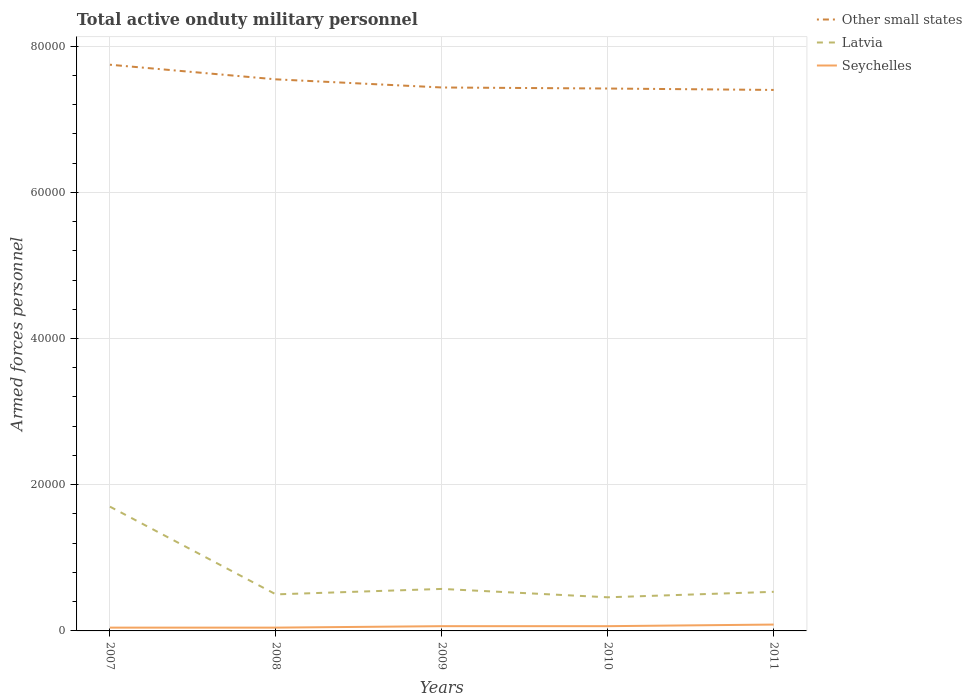Across all years, what is the maximum number of armed forces personnel in Other small states?
Provide a short and direct response. 7.40e+04. In which year was the number of armed forces personnel in Other small states maximum?
Give a very brief answer. 2011. What is the total number of armed forces personnel in Latvia in the graph?
Your response must be concise. 1.24e+04. What is the difference between the highest and the second highest number of armed forces personnel in Seychelles?
Make the answer very short. 420. What is the difference between the highest and the lowest number of armed forces personnel in Seychelles?
Your response must be concise. 3. Is the number of armed forces personnel in Other small states strictly greater than the number of armed forces personnel in Latvia over the years?
Your answer should be compact. No. How many lines are there?
Give a very brief answer. 3. How many years are there in the graph?
Give a very brief answer. 5. Does the graph contain grids?
Offer a very short reply. Yes. Where does the legend appear in the graph?
Give a very brief answer. Top right. How many legend labels are there?
Keep it short and to the point. 3. What is the title of the graph?
Your answer should be compact. Total active onduty military personnel. Does "Angola" appear as one of the legend labels in the graph?
Provide a succinct answer. No. What is the label or title of the Y-axis?
Provide a succinct answer. Armed forces personnel. What is the Armed forces personnel of Other small states in 2007?
Your response must be concise. 7.74e+04. What is the Armed forces personnel in Latvia in 2007?
Make the answer very short. 1.70e+04. What is the Armed forces personnel of Seychelles in 2007?
Your answer should be compact. 450. What is the Armed forces personnel in Other small states in 2008?
Your answer should be very brief. 7.54e+04. What is the Armed forces personnel in Seychelles in 2008?
Keep it short and to the point. 450. What is the Armed forces personnel of Other small states in 2009?
Ensure brevity in your answer.  7.43e+04. What is the Armed forces personnel of Latvia in 2009?
Provide a succinct answer. 5745. What is the Armed forces personnel in Seychelles in 2009?
Offer a terse response. 650. What is the Armed forces personnel of Other small states in 2010?
Provide a succinct answer. 7.42e+04. What is the Armed forces personnel in Latvia in 2010?
Offer a very short reply. 4600. What is the Armed forces personnel of Seychelles in 2010?
Make the answer very short. 650. What is the Armed forces personnel of Other small states in 2011?
Offer a very short reply. 7.40e+04. What is the Armed forces personnel of Latvia in 2011?
Offer a very short reply. 5350. What is the Armed forces personnel of Seychelles in 2011?
Give a very brief answer. 870. Across all years, what is the maximum Armed forces personnel of Other small states?
Provide a succinct answer. 7.74e+04. Across all years, what is the maximum Armed forces personnel in Latvia?
Offer a very short reply. 1.70e+04. Across all years, what is the maximum Armed forces personnel in Seychelles?
Provide a succinct answer. 870. Across all years, what is the minimum Armed forces personnel of Other small states?
Make the answer very short. 7.40e+04. Across all years, what is the minimum Armed forces personnel in Latvia?
Offer a very short reply. 4600. Across all years, what is the minimum Armed forces personnel in Seychelles?
Provide a succinct answer. 450. What is the total Armed forces personnel of Other small states in the graph?
Make the answer very short. 3.75e+05. What is the total Armed forces personnel in Latvia in the graph?
Offer a very short reply. 3.77e+04. What is the total Armed forces personnel in Seychelles in the graph?
Your answer should be compact. 3070. What is the difference between the Armed forces personnel of Other small states in 2007 and that in 2008?
Give a very brief answer. 2000. What is the difference between the Armed forces personnel in Latvia in 2007 and that in 2008?
Keep it short and to the point. 1.20e+04. What is the difference between the Armed forces personnel in Other small states in 2007 and that in 2009?
Offer a very short reply. 3113. What is the difference between the Armed forces personnel of Latvia in 2007 and that in 2009?
Your answer should be compact. 1.13e+04. What is the difference between the Armed forces personnel of Seychelles in 2007 and that in 2009?
Your answer should be very brief. -200. What is the difference between the Armed forces personnel in Other small states in 2007 and that in 2010?
Offer a terse response. 3256. What is the difference between the Armed forces personnel of Latvia in 2007 and that in 2010?
Your answer should be compact. 1.24e+04. What is the difference between the Armed forces personnel of Seychelles in 2007 and that in 2010?
Your answer should be compact. -200. What is the difference between the Armed forces personnel of Other small states in 2007 and that in 2011?
Provide a short and direct response. 3450. What is the difference between the Armed forces personnel of Latvia in 2007 and that in 2011?
Give a very brief answer. 1.16e+04. What is the difference between the Armed forces personnel in Seychelles in 2007 and that in 2011?
Your answer should be compact. -420. What is the difference between the Armed forces personnel in Other small states in 2008 and that in 2009?
Give a very brief answer. 1113. What is the difference between the Armed forces personnel of Latvia in 2008 and that in 2009?
Your response must be concise. -745. What is the difference between the Armed forces personnel in Seychelles in 2008 and that in 2009?
Offer a terse response. -200. What is the difference between the Armed forces personnel in Other small states in 2008 and that in 2010?
Make the answer very short. 1256. What is the difference between the Armed forces personnel in Latvia in 2008 and that in 2010?
Provide a short and direct response. 400. What is the difference between the Armed forces personnel in Seychelles in 2008 and that in 2010?
Keep it short and to the point. -200. What is the difference between the Armed forces personnel of Other small states in 2008 and that in 2011?
Your answer should be very brief. 1450. What is the difference between the Armed forces personnel of Latvia in 2008 and that in 2011?
Your answer should be compact. -350. What is the difference between the Armed forces personnel of Seychelles in 2008 and that in 2011?
Your answer should be compact. -420. What is the difference between the Armed forces personnel in Other small states in 2009 and that in 2010?
Provide a succinct answer. 143. What is the difference between the Armed forces personnel of Latvia in 2009 and that in 2010?
Your answer should be compact. 1145. What is the difference between the Armed forces personnel in Seychelles in 2009 and that in 2010?
Keep it short and to the point. 0. What is the difference between the Armed forces personnel in Other small states in 2009 and that in 2011?
Provide a succinct answer. 337. What is the difference between the Armed forces personnel of Latvia in 2009 and that in 2011?
Your answer should be very brief. 395. What is the difference between the Armed forces personnel in Seychelles in 2009 and that in 2011?
Provide a succinct answer. -220. What is the difference between the Armed forces personnel in Other small states in 2010 and that in 2011?
Your answer should be very brief. 194. What is the difference between the Armed forces personnel in Latvia in 2010 and that in 2011?
Ensure brevity in your answer.  -750. What is the difference between the Armed forces personnel in Seychelles in 2010 and that in 2011?
Your answer should be compact. -220. What is the difference between the Armed forces personnel of Other small states in 2007 and the Armed forces personnel of Latvia in 2008?
Your answer should be very brief. 7.24e+04. What is the difference between the Armed forces personnel of Other small states in 2007 and the Armed forces personnel of Seychelles in 2008?
Ensure brevity in your answer.  7.70e+04. What is the difference between the Armed forces personnel of Latvia in 2007 and the Armed forces personnel of Seychelles in 2008?
Your answer should be compact. 1.66e+04. What is the difference between the Armed forces personnel of Other small states in 2007 and the Armed forces personnel of Latvia in 2009?
Keep it short and to the point. 7.17e+04. What is the difference between the Armed forces personnel in Other small states in 2007 and the Armed forces personnel in Seychelles in 2009?
Make the answer very short. 7.68e+04. What is the difference between the Armed forces personnel in Latvia in 2007 and the Armed forces personnel in Seychelles in 2009?
Give a very brief answer. 1.64e+04. What is the difference between the Armed forces personnel in Other small states in 2007 and the Armed forces personnel in Latvia in 2010?
Keep it short and to the point. 7.28e+04. What is the difference between the Armed forces personnel in Other small states in 2007 and the Armed forces personnel in Seychelles in 2010?
Offer a very short reply. 7.68e+04. What is the difference between the Armed forces personnel of Latvia in 2007 and the Armed forces personnel of Seychelles in 2010?
Your answer should be very brief. 1.64e+04. What is the difference between the Armed forces personnel of Other small states in 2007 and the Armed forces personnel of Latvia in 2011?
Offer a terse response. 7.21e+04. What is the difference between the Armed forces personnel of Other small states in 2007 and the Armed forces personnel of Seychelles in 2011?
Provide a short and direct response. 7.66e+04. What is the difference between the Armed forces personnel of Latvia in 2007 and the Armed forces personnel of Seychelles in 2011?
Keep it short and to the point. 1.61e+04. What is the difference between the Armed forces personnel in Other small states in 2008 and the Armed forces personnel in Latvia in 2009?
Offer a very short reply. 6.97e+04. What is the difference between the Armed forces personnel of Other small states in 2008 and the Armed forces personnel of Seychelles in 2009?
Keep it short and to the point. 7.48e+04. What is the difference between the Armed forces personnel of Latvia in 2008 and the Armed forces personnel of Seychelles in 2009?
Keep it short and to the point. 4350. What is the difference between the Armed forces personnel in Other small states in 2008 and the Armed forces personnel in Latvia in 2010?
Keep it short and to the point. 7.08e+04. What is the difference between the Armed forces personnel of Other small states in 2008 and the Armed forces personnel of Seychelles in 2010?
Ensure brevity in your answer.  7.48e+04. What is the difference between the Armed forces personnel of Latvia in 2008 and the Armed forces personnel of Seychelles in 2010?
Offer a very short reply. 4350. What is the difference between the Armed forces personnel of Other small states in 2008 and the Armed forces personnel of Latvia in 2011?
Offer a very short reply. 7.01e+04. What is the difference between the Armed forces personnel of Other small states in 2008 and the Armed forces personnel of Seychelles in 2011?
Your answer should be compact. 7.46e+04. What is the difference between the Armed forces personnel in Latvia in 2008 and the Armed forces personnel in Seychelles in 2011?
Give a very brief answer. 4130. What is the difference between the Armed forces personnel of Other small states in 2009 and the Armed forces personnel of Latvia in 2010?
Your response must be concise. 6.97e+04. What is the difference between the Armed forces personnel in Other small states in 2009 and the Armed forces personnel in Seychelles in 2010?
Keep it short and to the point. 7.37e+04. What is the difference between the Armed forces personnel of Latvia in 2009 and the Armed forces personnel of Seychelles in 2010?
Your answer should be compact. 5095. What is the difference between the Armed forces personnel in Other small states in 2009 and the Armed forces personnel in Latvia in 2011?
Offer a terse response. 6.90e+04. What is the difference between the Armed forces personnel of Other small states in 2009 and the Armed forces personnel of Seychelles in 2011?
Your answer should be very brief. 7.35e+04. What is the difference between the Armed forces personnel in Latvia in 2009 and the Armed forces personnel in Seychelles in 2011?
Make the answer very short. 4875. What is the difference between the Armed forces personnel of Other small states in 2010 and the Armed forces personnel of Latvia in 2011?
Make the answer very short. 6.88e+04. What is the difference between the Armed forces personnel in Other small states in 2010 and the Armed forces personnel in Seychelles in 2011?
Your answer should be very brief. 7.33e+04. What is the difference between the Armed forces personnel of Latvia in 2010 and the Armed forces personnel of Seychelles in 2011?
Provide a short and direct response. 3730. What is the average Armed forces personnel of Other small states per year?
Your answer should be compact. 7.51e+04. What is the average Armed forces personnel of Latvia per year?
Provide a short and direct response. 7539. What is the average Armed forces personnel of Seychelles per year?
Provide a succinct answer. 614. In the year 2007, what is the difference between the Armed forces personnel in Other small states and Armed forces personnel in Latvia?
Provide a succinct answer. 6.04e+04. In the year 2007, what is the difference between the Armed forces personnel of Other small states and Armed forces personnel of Seychelles?
Provide a short and direct response. 7.70e+04. In the year 2007, what is the difference between the Armed forces personnel in Latvia and Armed forces personnel in Seychelles?
Keep it short and to the point. 1.66e+04. In the year 2008, what is the difference between the Armed forces personnel in Other small states and Armed forces personnel in Latvia?
Offer a very short reply. 7.04e+04. In the year 2008, what is the difference between the Armed forces personnel in Other small states and Armed forces personnel in Seychelles?
Your answer should be very brief. 7.50e+04. In the year 2008, what is the difference between the Armed forces personnel in Latvia and Armed forces personnel in Seychelles?
Make the answer very short. 4550. In the year 2009, what is the difference between the Armed forces personnel in Other small states and Armed forces personnel in Latvia?
Offer a terse response. 6.86e+04. In the year 2009, what is the difference between the Armed forces personnel in Other small states and Armed forces personnel in Seychelles?
Your answer should be very brief. 7.37e+04. In the year 2009, what is the difference between the Armed forces personnel of Latvia and Armed forces personnel of Seychelles?
Give a very brief answer. 5095. In the year 2010, what is the difference between the Armed forces personnel of Other small states and Armed forces personnel of Latvia?
Your response must be concise. 6.96e+04. In the year 2010, what is the difference between the Armed forces personnel in Other small states and Armed forces personnel in Seychelles?
Ensure brevity in your answer.  7.35e+04. In the year 2010, what is the difference between the Armed forces personnel of Latvia and Armed forces personnel of Seychelles?
Ensure brevity in your answer.  3950. In the year 2011, what is the difference between the Armed forces personnel of Other small states and Armed forces personnel of Latvia?
Ensure brevity in your answer.  6.86e+04. In the year 2011, what is the difference between the Armed forces personnel in Other small states and Armed forces personnel in Seychelles?
Make the answer very short. 7.31e+04. In the year 2011, what is the difference between the Armed forces personnel in Latvia and Armed forces personnel in Seychelles?
Provide a short and direct response. 4480. What is the ratio of the Armed forces personnel in Other small states in 2007 to that in 2008?
Keep it short and to the point. 1.03. What is the ratio of the Armed forces personnel in Other small states in 2007 to that in 2009?
Give a very brief answer. 1.04. What is the ratio of the Armed forces personnel of Latvia in 2007 to that in 2009?
Provide a short and direct response. 2.96. What is the ratio of the Armed forces personnel of Seychelles in 2007 to that in 2009?
Provide a succinct answer. 0.69. What is the ratio of the Armed forces personnel in Other small states in 2007 to that in 2010?
Your answer should be very brief. 1.04. What is the ratio of the Armed forces personnel of Latvia in 2007 to that in 2010?
Provide a short and direct response. 3.7. What is the ratio of the Armed forces personnel of Seychelles in 2007 to that in 2010?
Keep it short and to the point. 0.69. What is the ratio of the Armed forces personnel in Other small states in 2007 to that in 2011?
Ensure brevity in your answer.  1.05. What is the ratio of the Armed forces personnel in Latvia in 2007 to that in 2011?
Make the answer very short. 3.18. What is the ratio of the Armed forces personnel in Seychelles in 2007 to that in 2011?
Ensure brevity in your answer.  0.52. What is the ratio of the Armed forces personnel in Other small states in 2008 to that in 2009?
Provide a succinct answer. 1.01. What is the ratio of the Armed forces personnel of Latvia in 2008 to that in 2009?
Ensure brevity in your answer.  0.87. What is the ratio of the Armed forces personnel of Seychelles in 2008 to that in 2009?
Your answer should be compact. 0.69. What is the ratio of the Armed forces personnel in Other small states in 2008 to that in 2010?
Give a very brief answer. 1.02. What is the ratio of the Armed forces personnel of Latvia in 2008 to that in 2010?
Ensure brevity in your answer.  1.09. What is the ratio of the Armed forces personnel in Seychelles in 2008 to that in 2010?
Provide a short and direct response. 0.69. What is the ratio of the Armed forces personnel of Other small states in 2008 to that in 2011?
Offer a very short reply. 1.02. What is the ratio of the Armed forces personnel of Latvia in 2008 to that in 2011?
Your response must be concise. 0.93. What is the ratio of the Armed forces personnel in Seychelles in 2008 to that in 2011?
Offer a very short reply. 0.52. What is the ratio of the Armed forces personnel in Latvia in 2009 to that in 2010?
Your response must be concise. 1.25. What is the ratio of the Armed forces personnel in Other small states in 2009 to that in 2011?
Provide a succinct answer. 1. What is the ratio of the Armed forces personnel of Latvia in 2009 to that in 2011?
Your response must be concise. 1.07. What is the ratio of the Armed forces personnel in Seychelles in 2009 to that in 2011?
Make the answer very short. 0.75. What is the ratio of the Armed forces personnel in Other small states in 2010 to that in 2011?
Give a very brief answer. 1. What is the ratio of the Armed forces personnel in Latvia in 2010 to that in 2011?
Provide a succinct answer. 0.86. What is the ratio of the Armed forces personnel of Seychelles in 2010 to that in 2011?
Provide a short and direct response. 0.75. What is the difference between the highest and the second highest Armed forces personnel in Other small states?
Keep it short and to the point. 2000. What is the difference between the highest and the second highest Armed forces personnel in Latvia?
Provide a succinct answer. 1.13e+04. What is the difference between the highest and the second highest Armed forces personnel in Seychelles?
Provide a succinct answer. 220. What is the difference between the highest and the lowest Armed forces personnel in Other small states?
Make the answer very short. 3450. What is the difference between the highest and the lowest Armed forces personnel in Latvia?
Your answer should be very brief. 1.24e+04. What is the difference between the highest and the lowest Armed forces personnel in Seychelles?
Offer a very short reply. 420. 